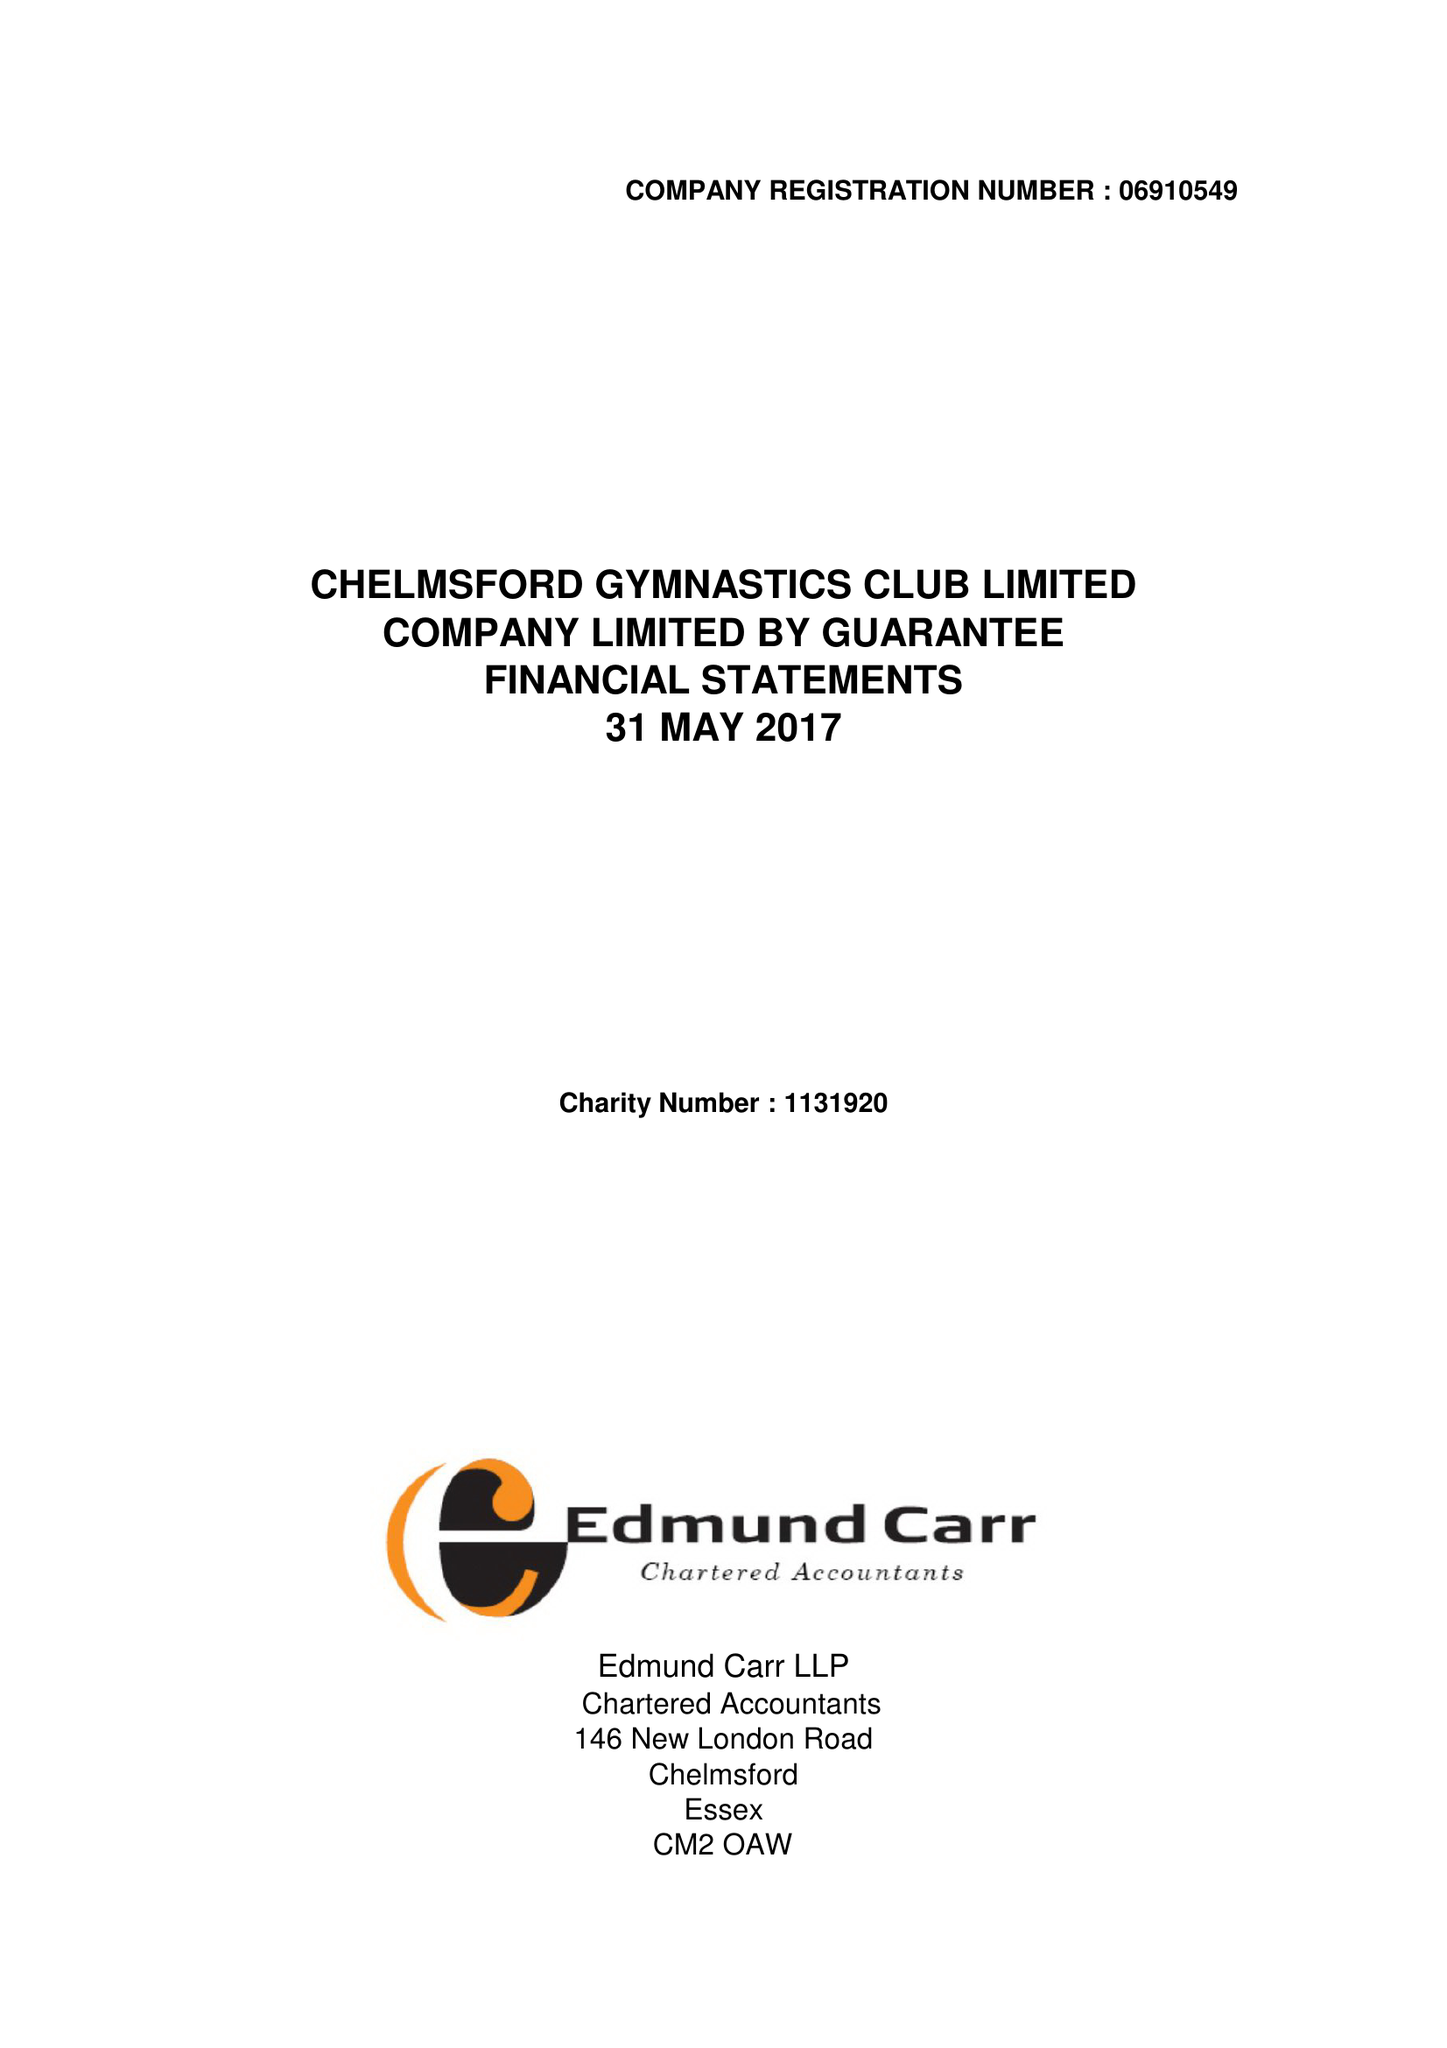What is the value for the report_date?
Answer the question using a single word or phrase. 2017-05-31 